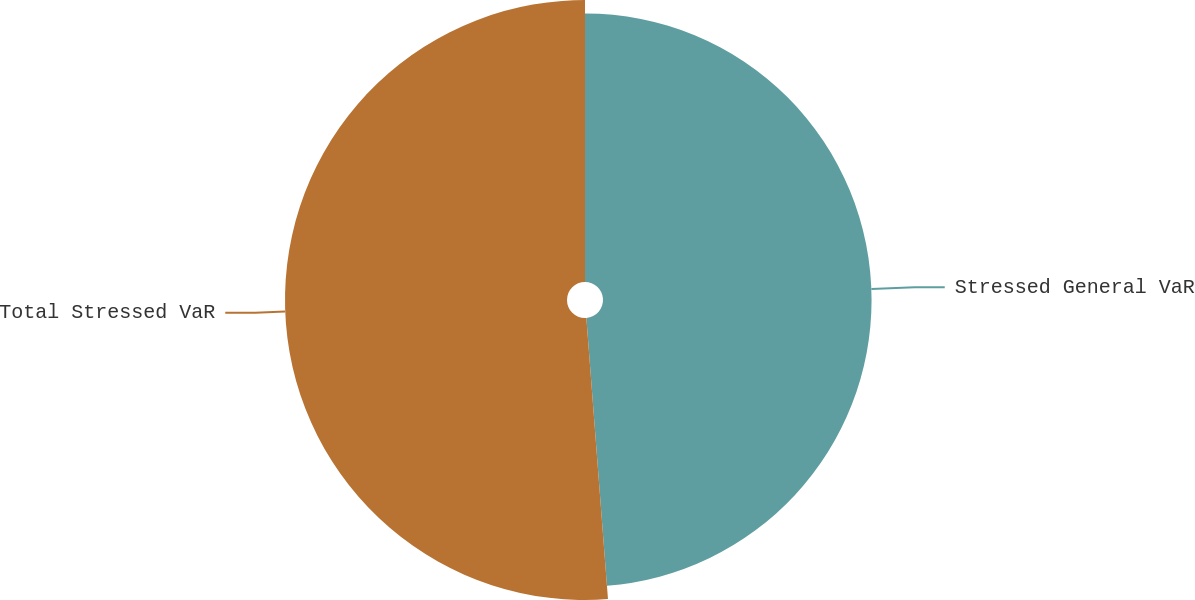Convert chart to OTSL. <chart><loc_0><loc_0><loc_500><loc_500><pie_chart><fcel>Stressed General VaR<fcel>Total Stressed VaR<nl><fcel>48.78%<fcel>51.22%<nl></chart> 